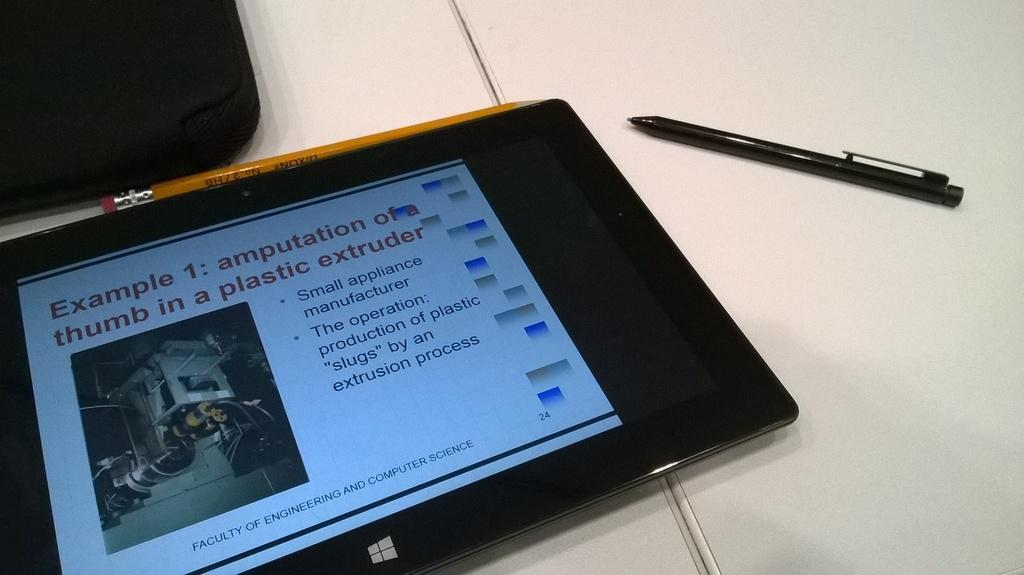What object is located on the table in the image? There is a tab on the table. What stationery items can be seen on the table? There is a pencil and a pen on the table. What type of bag is on the table? There is a bag on the table. What type of quilt is covering the bed in the image? There is no bed or quilt present in the image; it only features a table with objects on it. What flavor of cake is visible on the table in the image? There is no cake present in the image; it only features a table with objects on it. 